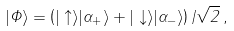<formula> <loc_0><loc_0><loc_500><loc_500>| \Phi \rangle = \left ( | \uparrow \rangle | \alpha _ { + } \rangle + | \downarrow \rangle | \alpha _ { - } \rangle \right ) / \sqrt { 2 } \, ,</formula> 